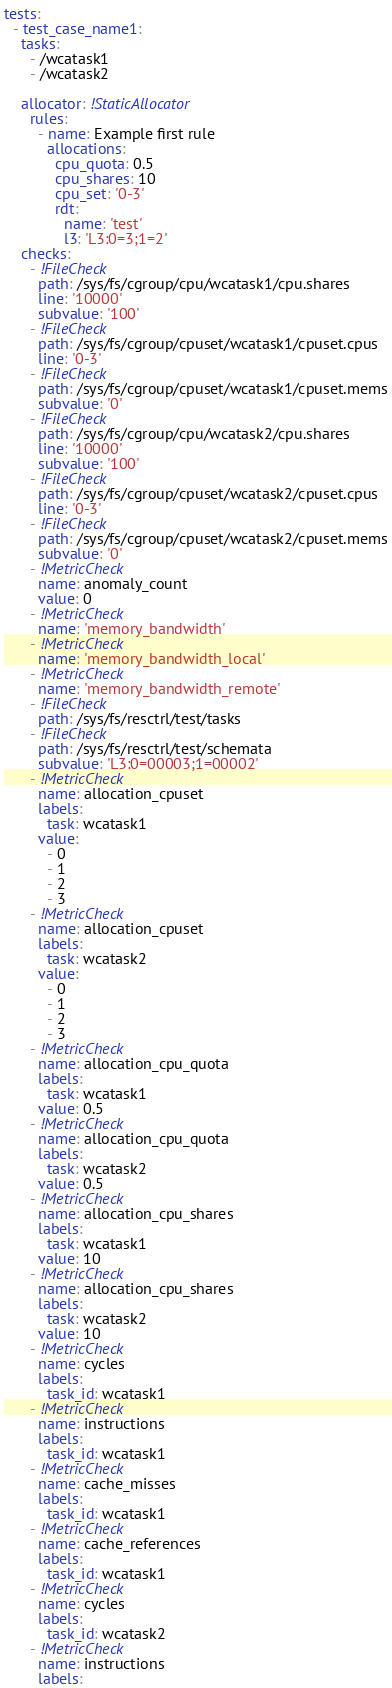<code> <loc_0><loc_0><loc_500><loc_500><_YAML_>tests:
  - test_case_name1:
    tasks:
      - /wcatask1
      - /wcatask2

    allocator: !StaticAllocator
      rules:
        - name: Example first rule
          allocations:
            cpu_quota: 0.5
            cpu_shares: 10
            cpu_set: '0-3'
            rdt:
              name: 'test'
              l3: 'L3:0=3;1=2'
    checks:
      - !FileCheck
        path: /sys/fs/cgroup/cpu/wcatask1/cpu.shares
        line: '10000'
        subvalue: '100'
      - !FileCheck
        path: /sys/fs/cgroup/cpuset/wcatask1/cpuset.cpus
        line: '0-3'
      - !FileCheck
        path: /sys/fs/cgroup/cpuset/wcatask1/cpuset.mems
        subvalue: '0'
      - !FileCheck
        path: /sys/fs/cgroup/cpu/wcatask2/cpu.shares
        line: '10000'
        subvalue: '100'
      - !FileCheck
        path: /sys/fs/cgroup/cpuset/wcatask2/cpuset.cpus
        line: '0-3'
      - !FileCheck
        path: /sys/fs/cgroup/cpuset/wcatask2/cpuset.mems
        subvalue: '0'
      - !MetricCheck
        name: anomaly_count
        value: 0
      - !MetricCheck
        name: 'memory_bandwidth' 
      - !MetricCheck
        name: 'memory_bandwidth_local' 
      - !MetricCheck
        name: 'memory_bandwidth_remote' 
      - !FileCheck
        path: /sys/fs/resctrl/test/tasks
      - !FileCheck
        path: /sys/fs/resctrl/test/schemata
        subvalue: 'L3:0=00003;1=00002'
      - !MetricCheck
        name: allocation_cpuset
        labels:
          task: wcatask1
        value:
          - 0
          - 1
          - 2
          - 3
      - !MetricCheck
        name: allocation_cpuset
        labels:
          task: wcatask2
        value:
          - 0
          - 1
          - 2
          - 3
      - !MetricCheck
        name: allocation_cpu_quota
        labels:
          task: wcatask1
        value: 0.5
      - !MetricCheck
        name: allocation_cpu_quota
        labels:
          task: wcatask2
        value: 0.5
      - !MetricCheck
        name: allocation_cpu_shares
        labels:
          task: wcatask1
        value: 10
      - !MetricCheck
        name: allocation_cpu_shares
        labels:
          task: wcatask2
        value: 10
      - !MetricCheck
        name: cycles
        labels:
          task_id: wcatask1
      - !MetricCheck
        name: instructions
        labels:
          task_id: wcatask1
      - !MetricCheck
        name: cache_misses
        labels:
          task_id: wcatask1
      - !MetricCheck
        name: cache_references
        labels:
          task_id: wcatask1
      - !MetricCheck
        name: cycles
        labels:
          task_id: wcatask2
      - !MetricCheck
        name: instructions
        labels:</code> 